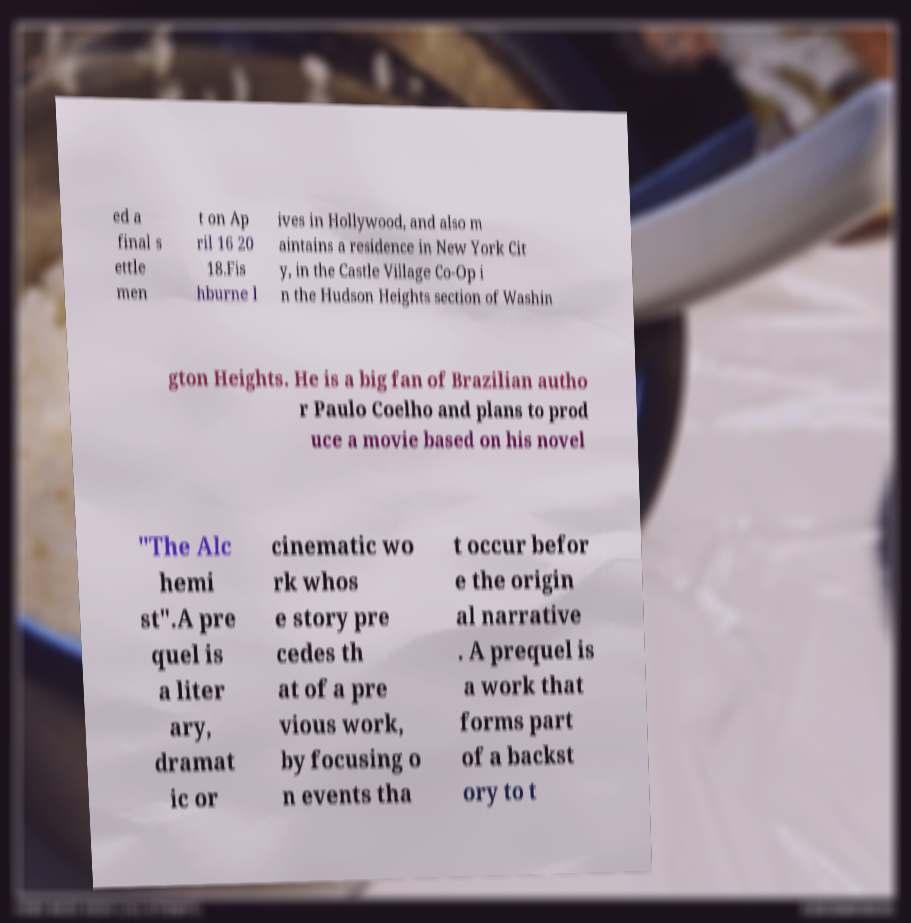Can you read and provide the text displayed in the image?This photo seems to have some interesting text. Can you extract and type it out for me? ed a final s ettle men t on Ap ril 16 20 18.Fis hburne l ives in Hollywood, and also m aintains a residence in New York Cit y, in the Castle Village Co-Op i n the Hudson Heights section of Washin gton Heights. He is a big fan of Brazilian autho r Paulo Coelho and plans to prod uce a movie based on his novel "The Alc hemi st".A pre quel is a liter ary, dramat ic or cinematic wo rk whos e story pre cedes th at of a pre vious work, by focusing o n events tha t occur befor e the origin al narrative . A prequel is a work that forms part of a backst ory to t 